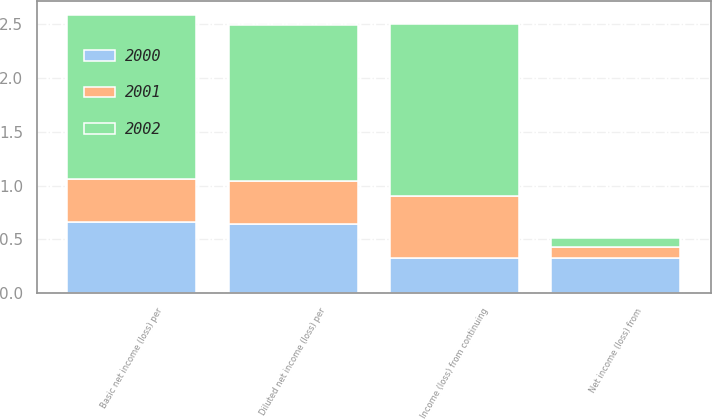<chart> <loc_0><loc_0><loc_500><loc_500><stacked_bar_chart><ecel><fcel>Income (loss) from continuing<fcel>Net income (loss) from<fcel>Basic net income (loss) per<fcel>Diluted net income (loss) per<nl><fcel>2002<fcel>1.6<fcel>0.08<fcel>1.52<fcel>1.45<nl><fcel>2001<fcel>0.57<fcel>0.1<fcel>0.4<fcel>0.4<nl><fcel>2000<fcel>0.33<fcel>0.33<fcel>0.66<fcel>0.64<nl></chart> 